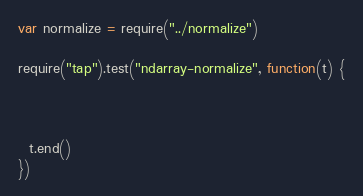Convert code to text. <code><loc_0><loc_0><loc_500><loc_500><_JavaScript_>
var normalize = require("../normalize")

require("tap").test("ndarray-normalize", function(t) {

  

  t.end()
})</code> 